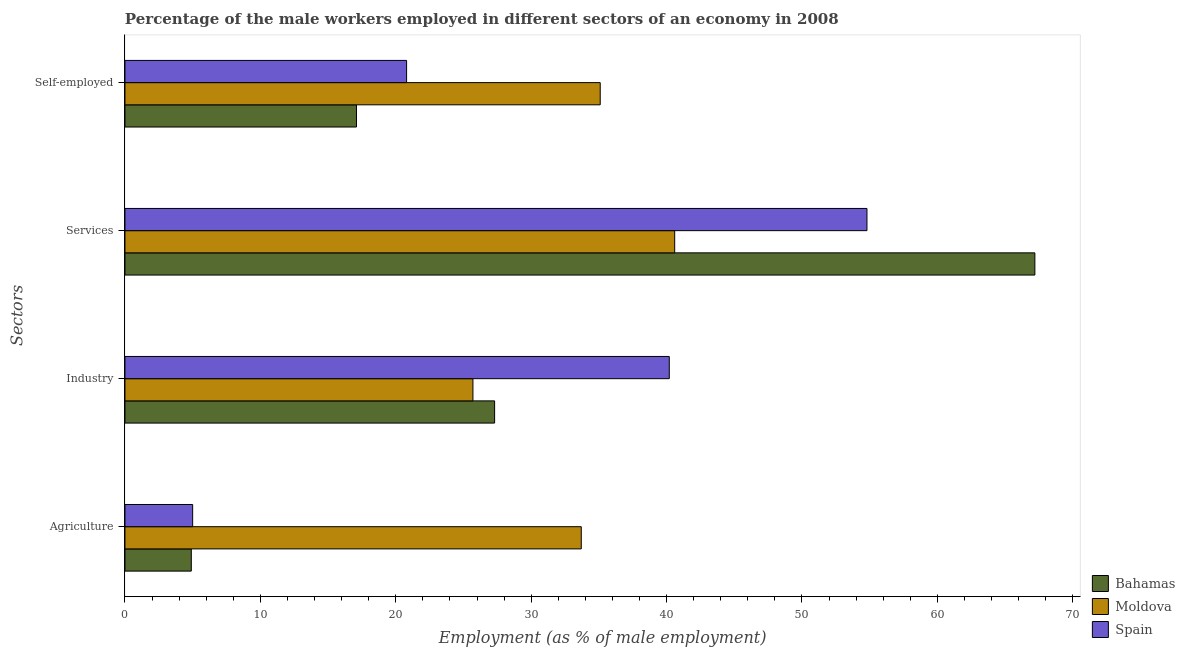How many different coloured bars are there?
Give a very brief answer. 3. Are the number of bars per tick equal to the number of legend labels?
Your response must be concise. Yes. What is the label of the 3rd group of bars from the top?
Make the answer very short. Industry. What is the percentage of male workers in services in Bahamas?
Ensure brevity in your answer.  67.2. Across all countries, what is the maximum percentage of male workers in agriculture?
Offer a very short reply. 33.7. Across all countries, what is the minimum percentage of self employed male workers?
Provide a short and direct response. 17.1. In which country was the percentage of male workers in services maximum?
Provide a succinct answer. Bahamas. In which country was the percentage of male workers in agriculture minimum?
Offer a terse response. Bahamas. What is the total percentage of male workers in services in the graph?
Offer a terse response. 162.6. What is the difference between the percentage of self employed male workers in Spain and that in Moldova?
Your response must be concise. -14.3. What is the difference between the percentage of male workers in industry in Spain and the percentage of self employed male workers in Bahamas?
Your answer should be compact. 23.1. What is the average percentage of male workers in industry per country?
Ensure brevity in your answer.  31.07. What is the difference between the percentage of self employed male workers and percentage of male workers in services in Bahamas?
Your response must be concise. -50.1. In how many countries, is the percentage of self employed male workers greater than 6 %?
Your response must be concise. 3. What is the ratio of the percentage of male workers in agriculture in Bahamas to that in Moldova?
Keep it short and to the point. 0.15. Is the percentage of male workers in services in Spain less than that in Bahamas?
Offer a very short reply. Yes. What is the difference between the highest and the second highest percentage of male workers in services?
Give a very brief answer. 12.4. What is the difference between the highest and the lowest percentage of self employed male workers?
Your answer should be very brief. 18. In how many countries, is the percentage of self employed male workers greater than the average percentage of self employed male workers taken over all countries?
Your answer should be very brief. 1. Is it the case that in every country, the sum of the percentage of male workers in services and percentage of self employed male workers is greater than the sum of percentage of male workers in agriculture and percentage of male workers in industry?
Your answer should be compact. Yes. What does the 3rd bar from the top in Agriculture represents?
Give a very brief answer. Bahamas. What does the 1st bar from the bottom in Industry represents?
Make the answer very short. Bahamas. Is it the case that in every country, the sum of the percentage of male workers in agriculture and percentage of male workers in industry is greater than the percentage of male workers in services?
Offer a terse response. No. Where does the legend appear in the graph?
Give a very brief answer. Bottom right. How are the legend labels stacked?
Your answer should be compact. Vertical. What is the title of the graph?
Ensure brevity in your answer.  Percentage of the male workers employed in different sectors of an economy in 2008. Does "St. Lucia" appear as one of the legend labels in the graph?
Give a very brief answer. No. What is the label or title of the X-axis?
Make the answer very short. Employment (as % of male employment). What is the label or title of the Y-axis?
Your response must be concise. Sectors. What is the Employment (as % of male employment) of Bahamas in Agriculture?
Provide a succinct answer. 4.9. What is the Employment (as % of male employment) of Moldova in Agriculture?
Make the answer very short. 33.7. What is the Employment (as % of male employment) in Bahamas in Industry?
Provide a succinct answer. 27.3. What is the Employment (as % of male employment) of Moldova in Industry?
Keep it short and to the point. 25.7. What is the Employment (as % of male employment) of Spain in Industry?
Your answer should be compact. 40.2. What is the Employment (as % of male employment) in Bahamas in Services?
Keep it short and to the point. 67.2. What is the Employment (as % of male employment) in Moldova in Services?
Offer a terse response. 40.6. What is the Employment (as % of male employment) of Spain in Services?
Provide a short and direct response. 54.8. What is the Employment (as % of male employment) in Bahamas in Self-employed?
Ensure brevity in your answer.  17.1. What is the Employment (as % of male employment) in Moldova in Self-employed?
Provide a succinct answer. 35.1. What is the Employment (as % of male employment) in Spain in Self-employed?
Provide a succinct answer. 20.8. Across all Sectors, what is the maximum Employment (as % of male employment) in Bahamas?
Give a very brief answer. 67.2. Across all Sectors, what is the maximum Employment (as % of male employment) in Moldova?
Provide a short and direct response. 40.6. Across all Sectors, what is the maximum Employment (as % of male employment) of Spain?
Keep it short and to the point. 54.8. Across all Sectors, what is the minimum Employment (as % of male employment) in Bahamas?
Your response must be concise. 4.9. Across all Sectors, what is the minimum Employment (as % of male employment) in Moldova?
Make the answer very short. 25.7. What is the total Employment (as % of male employment) of Bahamas in the graph?
Your answer should be very brief. 116.5. What is the total Employment (as % of male employment) in Moldova in the graph?
Your answer should be compact. 135.1. What is the total Employment (as % of male employment) of Spain in the graph?
Keep it short and to the point. 120.8. What is the difference between the Employment (as % of male employment) in Bahamas in Agriculture and that in Industry?
Your answer should be compact. -22.4. What is the difference between the Employment (as % of male employment) of Spain in Agriculture and that in Industry?
Give a very brief answer. -35.2. What is the difference between the Employment (as % of male employment) of Bahamas in Agriculture and that in Services?
Your answer should be very brief. -62.3. What is the difference between the Employment (as % of male employment) of Moldova in Agriculture and that in Services?
Your answer should be very brief. -6.9. What is the difference between the Employment (as % of male employment) in Spain in Agriculture and that in Services?
Keep it short and to the point. -49.8. What is the difference between the Employment (as % of male employment) of Spain in Agriculture and that in Self-employed?
Your answer should be very brief. -15.8. What is the difference between the Employment (as % of male employment) of Bahamas in Industry and that in Services?
Your answer should be compact. -39.9. What is the difference between the Employment (as % of male employment) in Moldova in Industry and that in Services?
Keep it short and to the point. -14.9. What is the difference between the Employment (as % of male employment) in Spain in Industry and that in Services?
Provide a succinct answer. -14.6. What is the difference between the Employment (as % of male employment) in Moldova in Industry and that in Self-employed?
Offer a very short reply. -9.4. What is the difference between the Employment (as % of male employment) of Spain in Industry and that in Self-employed?
Provide a succinct answer. 19.4. What is the difference between the Employment (as % of male employment) in Bahamas in Services and that in Self-employed?
Your answer should be very brief. 50.1. What is the difference between the Employment (as % of male employment) in Moldova in Services and that in Self-employed?
Keep it short and to the point. 5.5. What is the difference between the Employment (as % of male employment) in Spain in Services and that in Self-employed?
Provide a short and direct response. 34. What is the difference between the Employment (as % of male employment) in Bahamas in Agriculture and the Employment (as % of male employment) in Moldova in Industry?
Provide a succinct answer. -20.8. What is the difference between the Employment (as % of male employment) of Bahamas in Agriculture and the Employment (as % of male employment) of Spain in Industry?
Offer a terse response. -35.3. What is the difference between the Employment (as % of male employment) of Moldova in Agriculture and the Employment (as % of male employment) of Spain in Industry?
Your response must be concise. -6.5. What is the difference between the Employment (as % of male employment) of Bahamas in Agriculture and the Employment (as % of male employment) of Moldova in Services?
Your response must be concise. -35.7. What is the difference between the Employment (as % of male employment) in Bahamas in Agriculture and the Employment (as % of male employment) in Spain in Services?
Offer a terse response. -49.9. What is the difference between the Employment (as % of male employment) in Moldova in Agriculture and the Employment (as % of male employment) in Spain in Services?
Your answer should be compact. -21.1. What is the difference between the Employment (as % of male employment) of Bahamas in Agriculture and the Employment (as % of male employment) of Moldova in Self-employed?
Provide a succinct answer. -30.2. What is the difference between the Employment (as % of male employment) of Bahamas in Agriculture and the Employment (as % of male employment) of Spain in Self-employed?
Your answer should be compact. -15.9. What is the difference between the Employment (as % of male employment) of Moldova in Agriculture and the Employment (as % of male employment) of Spain in Self-employed?
Give a very brief answer. 12.9. What is the difference between the Employment (as % of male employment) in Bahamas in Industry and the Employment (as % of male employment) in Moldova in Services?
Your answer should be very brief. -13.3. What is the difference between the Employment (as % of male employment) of Bahamas in Industry and the Employment (as % of male employment) of Spain in Services?
Make the answer very short. -27.5. What is the difference between the Employment (as % of male employment) in Moldova in Industry and the Employment (as % of male employment) in Spain in Services?
Offer a very short reply. -29.1. What is the difference between the Employment (as % of male employment) of Bahamas in Industry and the Employment (as % of male employment) of Moldova in Self-employed?
Offer a terse response. -7.8. What is the difference between the Employment (as % of male employment) in Bahamas in Services and the Employment (as % of male employment) in Moldova in Self-employed?
Keep it short and to the point. 32.1. What is the difference between the Employment (as % of male employment) in Bahamas in Services and the Employment (as % of male employment) in Spain in Self-employed?
Provide a succinct answer. 46.4. What is the difference between the Employment (as % of male employment) in Moldova in Services and the Employment (as % of male employment) in Spain in Self-employed?
Offer a terse response. 19.8. What is the average Employment (as % of male employment) of Bahamas per Sectors?
Your answer should be very brief. 29.12. What is the average Employment (as % of male employment) of Moldova per Sectors?
Give a very brief answer. 33.77. What is the average Employment (as % of male employment) in Spain per Sectors?
Provide a short and direct response. 30.2. What is the difference between the Employment (as % of male employment) of Bahamas and Employment (as % of male employment) of Moldova in Agriculture?
Keep it short and to the point. -28.8. What is the difference between the Employment (as % of male employment) in Bahamas and Employment (as % of male employment) in Spain in Agriculture?
Provide a short and direct response. -0.1. What is the difference between the Employment (as % of male employment) of Moldova and Employment (as % of male employment) of Spain in Agriculture?
Keep it short and to the point. 28.7. What is the difference between the Employment (as % of male employment) in Bahamas and Employment (as % of male employment) in Spain in Industry?
Your response must be concise. -12.9. What is the difference between the Employment (as % of male employment) in Bahamas and Employment (as % of male employment) in Moldova in Services?
Provide a succinct answer. 26.6. What is the difference between the Employment (as % of male employment) of Moldova and Employment (as % of male employment) of Spain in Services?
Offer a very short reply. -14.2. What is the ratio of the Employment (as % of male employment) in Bahamas in Agriculture to that in Industry?
Your answer should be very brief. 0.18. What is the ratio of the Employment (as % of male employment) of Moldova in Agriculture to that in Industry?
Ensure brevity in your answer.  1.31. What is the ratio of the Employment (as % of male employment) of Spain in Agriculture to that in Industry?
Your answer should be compact. 0.12. What is the ratio of the Employment (as % of male employment) of Bahamas in Agriculture to that in Services?
Your response must be concise. 0.07. What is the ratio of the Employment (as % of male employment) of Moldova in Agriculture to that in Services?
Offer a very short reply. 0.83. What is the ratio of the Employment (as % of male employment) in Spain in Agriculture to that in Services?
Your answer should be compact. 0.09. What is the ratio of the Employment (as % of male employment) in Bahamas in Agriculture to that in Self-employed?
Provide a short and direct response. 0.29. What is the ratio of the Employment (as % of male employment) of Moldova in Agriculture to that in Self-employed?
Your answer should be compact. 0.96. What is the ratio of the Employment (as % of male employment) in Spain in Agriculture to that in Self-employed?
Ensure brevity in your answer.  0.24. What is the ratio of the Employment (as % of male employment) in Bahamas in Industry to that in Services?
Give a very brief answer. 0.41. What is the ratio of the Employment (as % of male employment) in Moldova in Industry to that in Services?
Offer a very short reply. 0.63. What is the ratio of the Employment (as % of male employment) of Spain in Industry to that in Services?
Give a very brief answer. 0.73. What is the ratio of the Employment (as % of male employment) of Bahamas in Industry to that in Self-employed?
Your response must be concise. 1.6. What is the ratio of the Employment (as % of male employment) of Moldova in Industry to that in Self-employed?
Keep it short and to the point. 0.73. What is the ratio of the Employment (as % of male employment) of Spain in Industry to that in Self-employed?
Offer a very short reply. 1.93. What is the ratio of the Employment (as % of male employment) of Bahamas in Services to that in Self-employed?
Give a very brief answer. 3.93. What is the ratio of the Employment (as % of male employment) in Moldova in Services to that in Self-employed?
Your answer should be very brief. 1.16. What is the ratio of the Employment (as % of male employment) in Spain in Services to that in Self-employed?
Offer a very short reply. 2.63. What is the difference between the highest and the second highest Employment (as % of male employment) in Bahamas?
Offer a terse response. 39.9. What is the difference between the highest and the second highest Employment (as % of male employment) of Moldova?
Keep it short and to the point. 5.5. What is the difference between the highest and the second highest Employment (as % of male employment) of Spain?
Provide a succinct answer. 14.6. What is the difference between the highest and the lowest Employment (as % of male employment) of Bahamas?
Make the answer very short. 62.3. What is the difference between the highest and the lowest Employment (as % of male employment) in Moldova?
Your answer should be very brief. 14.9. What is the difference between the highest and the lowest Employment (as % of male employment) in Spain?
Make the answer very short. 49.8. 